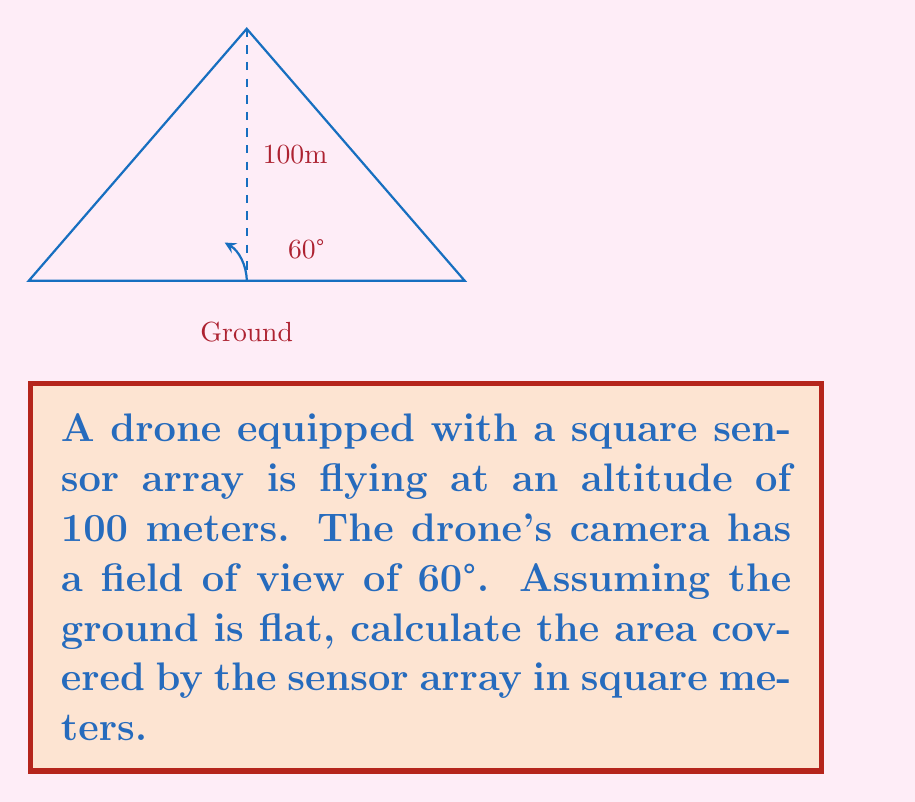Can you solve this math problem? Let's approach this step-by-step:

1) First, we need to understand that the area covered by the sensor array will be a square on the ground.

2) The field of view (FOV) of 60° forms an isosceles triangle from the drone to the ground, with the sensor area as its base.

3) We can split this isosceles triangle into two right triangles. Let's focus on one of these right triangles.

4) In this right triangle:
   - The adjacent side is the altitude (100m)
   - The angle is half of the FOV (30°)
   - We need to find half the width of the sensor area

5) We can use the tangent function to find half the width:

   $$\tan(30°) = \frac{\text{opposite}}{\text{adjacent}} = \frac{\text{half width}}{100}$$

6) Solving for the half width:

   $$\text{half width} = 100 \tan(30°) = 100 \cdot 0.577 = 57.7\text{m}$$

7) The full width of the sensor area is twice this:

   $$\text{full width} = 2 \cdot 57.7 = 115.4\text{m}$$

8) Since the sensor array is square, both sides are 115.4m.

9) The area of a square is the side length squared:

   $$\text{Area} = 115.4^2 = 13,317.16\text{m}^2$$

Therefore, the area covered by the drone's sensor array is approximately 13,317 square meters.
Answer: 13,317 m² 